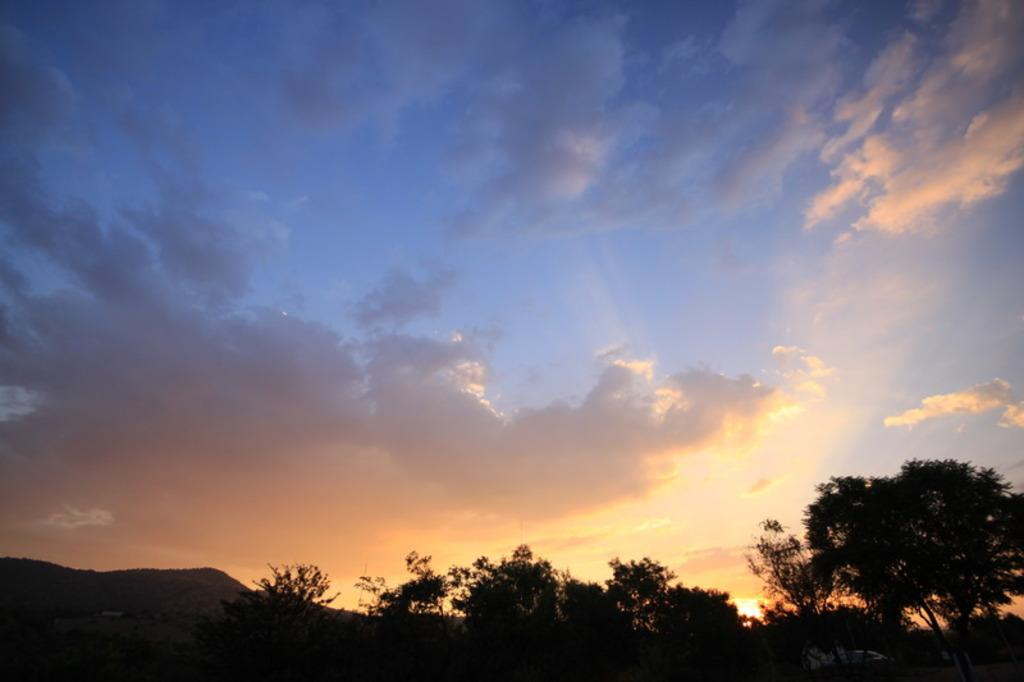What is the condition of the sky in the image? The sky in the image is cloudy. What type of natural vegetation can be seen in the image? There are trees visible in the image. What geographical feature is present in the image? There is a hill in the image. What type of metal can be seen on the floor in the image? There is no metal or floor present in the image; it features a cloudy sky, trees, and a hill. 